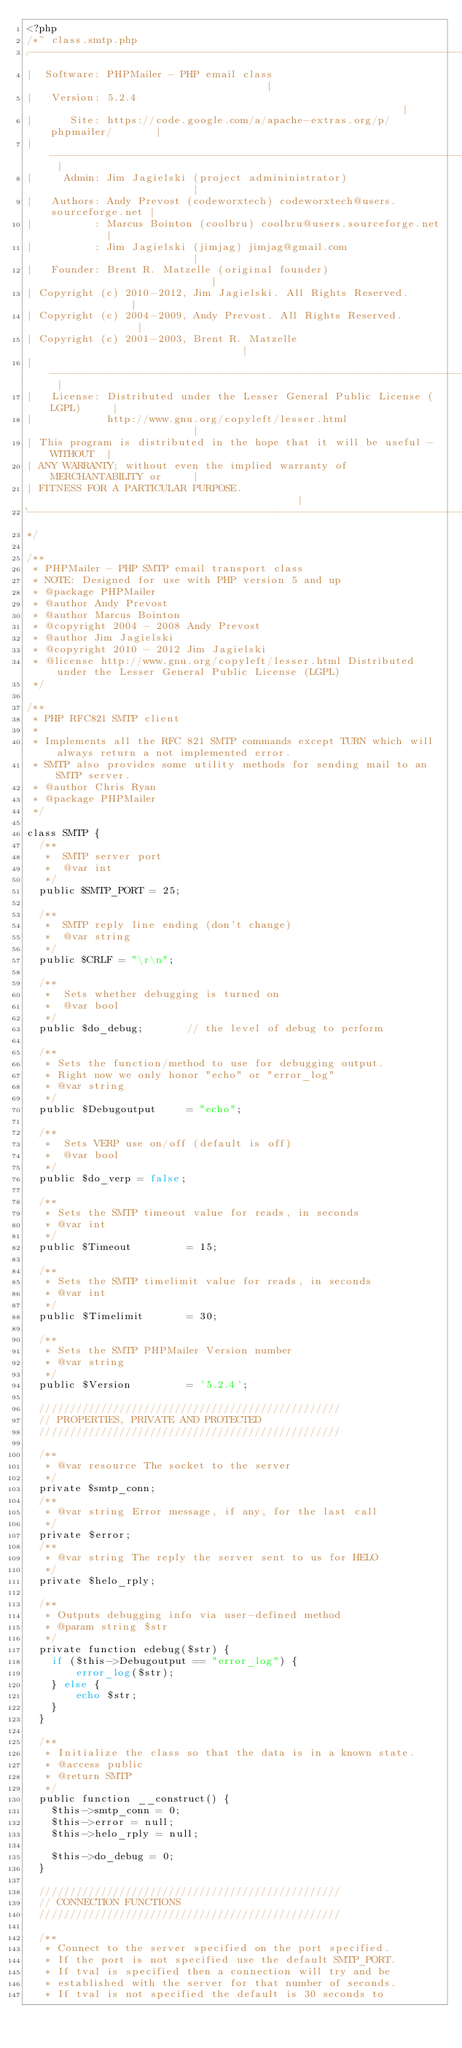<code> <loc_0><loc_0><loc_500><loc_500><_PHP_><?php
/*~ class.smtp.php
.---------------------------------------------------------------------------.
|  Software: PHPMailer - PHP email class                                    |
|   Version: 5.2.4                                                          |
|      Site: https://code.google.com/a/apache-extras.org/p/phpmailer/       |
| ------------------------------------------------------------------------- |
|     Admin: Jim Jagielski (project admininistrator)                        |
|   Authors: Andy Prevost (codeworxtech) codeworxtech@users.sourceforge.net |
|          : Marcus Bointon (coolbru) coolbru@users.sourceforge.net         |
|          : Jim Jagielski (jimjag) jimjag@gmail.com                        |
|   Founder: Brent R. Matzelle (original founder)                           |
| Copyright (c) 2010-2012, Jim Jagielski. All Rights Reserved.              |
| Copyright (c) 2004-2009, Andy Prevost. All Rights Reserved.               |
| Copyright (c) 2001-2003, Brent R. Matzelle                                |
| ------------------------------------------------------------------------- |
|   License: Distributed under the Lesser General Public License (LGPL)     |
|            http://www.gnu.org/copyleft/lesser.html                        |
| This program is distributed in the hope that it will be useful - WITHOUT  |
| ANY WARRANTY; without even the implied warranty of MERCHANTABILITY or     |
| FITNESS FOR A PARTICULAR PURPOSE.                                         |
'---------------------------------------------------------------------------'
*/

/**
 * PHPMailer - PHP SMTP email transport class
 * NOTE: Designed for use with PHP version 5 and up
 * @package PHPMailer
 * @author Andy Prevost
 * @author Marcus Bointon
 * @copyright 2004 - 2008 Andy Prevost
 * @author Jim Jagielski
 * @copyright 2010 - 2012 Jim Jagielski
 * @license http://www.gnu.org/copyleft/lesser.html Distributed under the Lesser General Public License (LGPL)
 */

/**
 * PHP RFC821 SMTP client
 *
 * Implements all the RFC 821 SMTP commands except TURN which will always return a not implemented error.
 * SMTP also provides some utility methods for sending mail to an SMTP server.
 * @author Chris Ryan
 * @package PHPMailer
 */

class SMTP {
  /**
   *  SMTP server port
   *  @var int
   */
  public $SMTP_PORT = 25;

  /**
   *  SMTP reply line ending (don't change)
   *  @var string
   */
  public $CRLF = "\r\n";

  /**
   *  Sets whether debugging is turned on
   *  @var bool
   */
  public $do_debug;       // the level of debug to perform

  /**
   * Sets the function/method to use for debugging output.
   * Right now we only honor "echo" or "error_log"
   * @var string
   */
  public $Debugoutput     = "echo";

  /**
   *  Sets VERP use on/off (default is off)
   *  @var bool
   */
  public $do_verp = false;

  /**
   * Sets the SMTP timeout value for reads, in seconds
   * @var int
   */
  public $Timeout         = 15;

  /**
   * Sets the SMTP timelimit value for reads, in seconds
   * @var int
   */
  public $Timelimit       = 30;

  /**
   * Sets the SMTP PHPMailer Version number
   * @var string
   */
  public $Version         = '5.2.4';

  /////////////////////////////////////////////////
  // PROPERTIES, PRIVATE AND PROTECTED
  /////////////////////////////////////////////////

  /**
   * @var resource The socket to the server
   */
  private $smtp_conn;
  /**
   * @var string Error message, if any, for the last call
   */
  private $error;
  /**
   * @var string The reply the server sent to us for HELO
   */
  private $helo_rply;

  /**
   * Outputs debugging info via user-defined method
   * @param string $str
   */
  private function edebug($str) {
    if ($this->Debugoutput == "error_log") {
        error_log($str);
    } else {
        echo $str;
    }
  }

  /**
   * Initialize the class so that the data is in a known state.
   * @access public
   * @return SMTP
   */
  public function __construct() {
    $this->smtp_conn = 0;
    $this->error = null;
    $this->helo_rply = null;

    $this->do_debug = 0;
  }

  /////////////////////////////////////////////////
  // CONNECTION FUNCTIONS
  /////////////////////////////////////////////////

  /**
   * Connect to the server specified on the port specified.
   * If the port is not specified use the default SMTP_PORT.
   * If tval is specified then a connection will try and be
   * established with the server for that number of seconds.
   * If tval is not specified the default is 30 seconds to</code> 